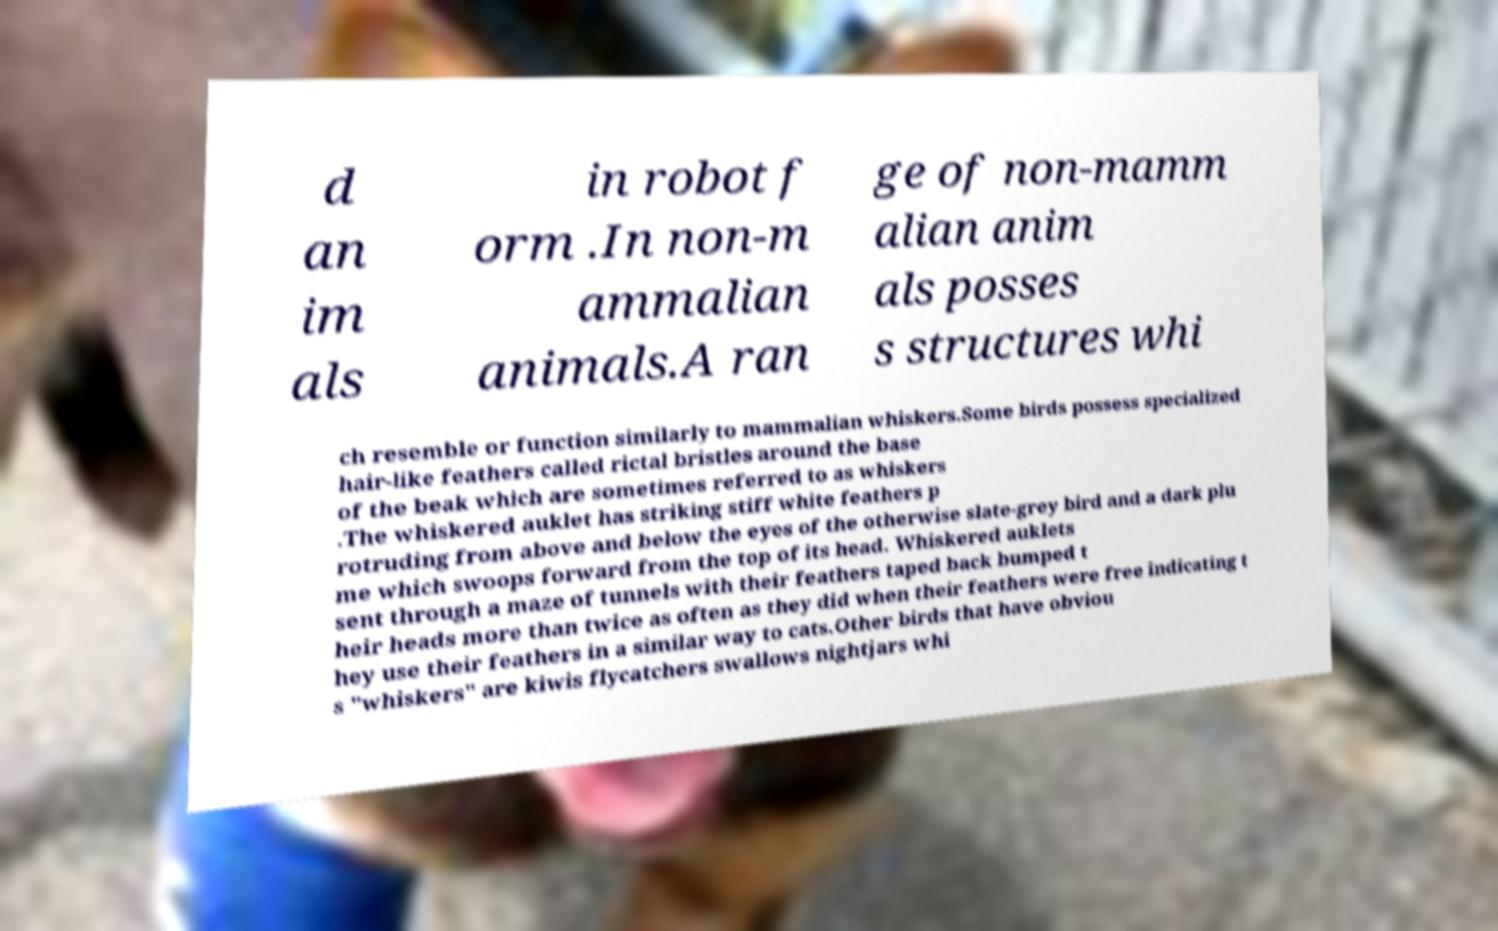Could you extract and type out the text from this image? d an im als in robot f orm .In non-m ammalian animals.A ran ge of non-mamm alian anim als posses s structures whi ch resemble or function similarly to mammalian whiskers.Some birds possess specialized hair-like feathers called rictal bristles around the base of the beak which are sometimes referred to as whiskers .The whiskered auklet has striking stiff white feathers p rotruding from above and below the eyes of the otherwise slate-grey bird and a dark plu me which swoops forward from the top of its head. Whiskered auklets sent through a maze of tunnels with their feathers taped back bumped t heir heads more than twice as often as they did when their feathers were free indicating t hey use their feathers in a similar way to cats.Other birds that have obviou s "whiskers" are kiwis flycatchers swallows nightjars whi 